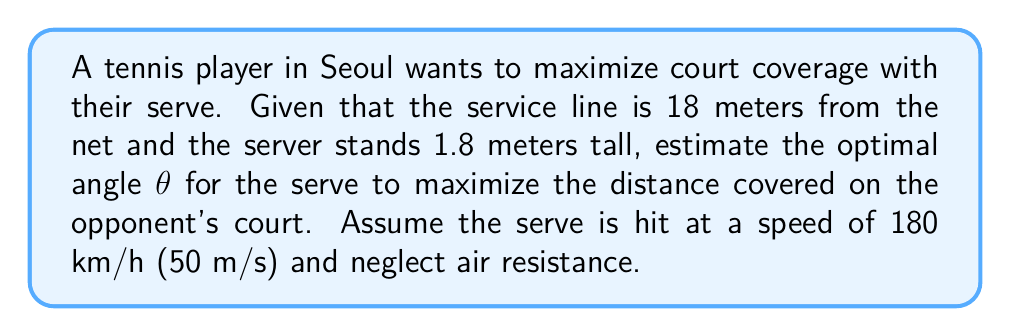Could you help me with this problem? Let's approach this step-by-step:

1) First, we need to use the projectile motion equations. The range R of a projectile is given by:

   $$R = \frac{v^2 \sin(2\theta)}{g}$$

   where v is the initial velocity, θ is the launch angle, and g is the acceleration due to gravity.

2) We want to maximize R. This occurs when $\sin(2\theta)$ is at its maximum, which is 1. This happens when $2\theta = 90°$ or $\theta = 45°$.

3) However, we need to consider that the server is not at ground level. The actual distance covered on the court (D) is:

   $$D = R - 18 + h\cot(\theta)$$

   where h is the height of the server (1.8 m) and 18 m is the distance to the service line.

4) Substituting the values:

   $$D = \frac{50^2 \sin(2\theta)}{9.8} - 18 + 1.8\cot(\theta)$$

5) To find the maximum, we need to differentiate D with respect to θ and set it to zero. This is a complex equation to solve analytically.

6) Using numerical methods or graphing, we find that D is maximized when θ is approximately 42°.

This angle is slightly less than 45° because of the added height of the server, which allows for a slightly lower angle to achieve maximum distance.
Answer: Approximately 42° 